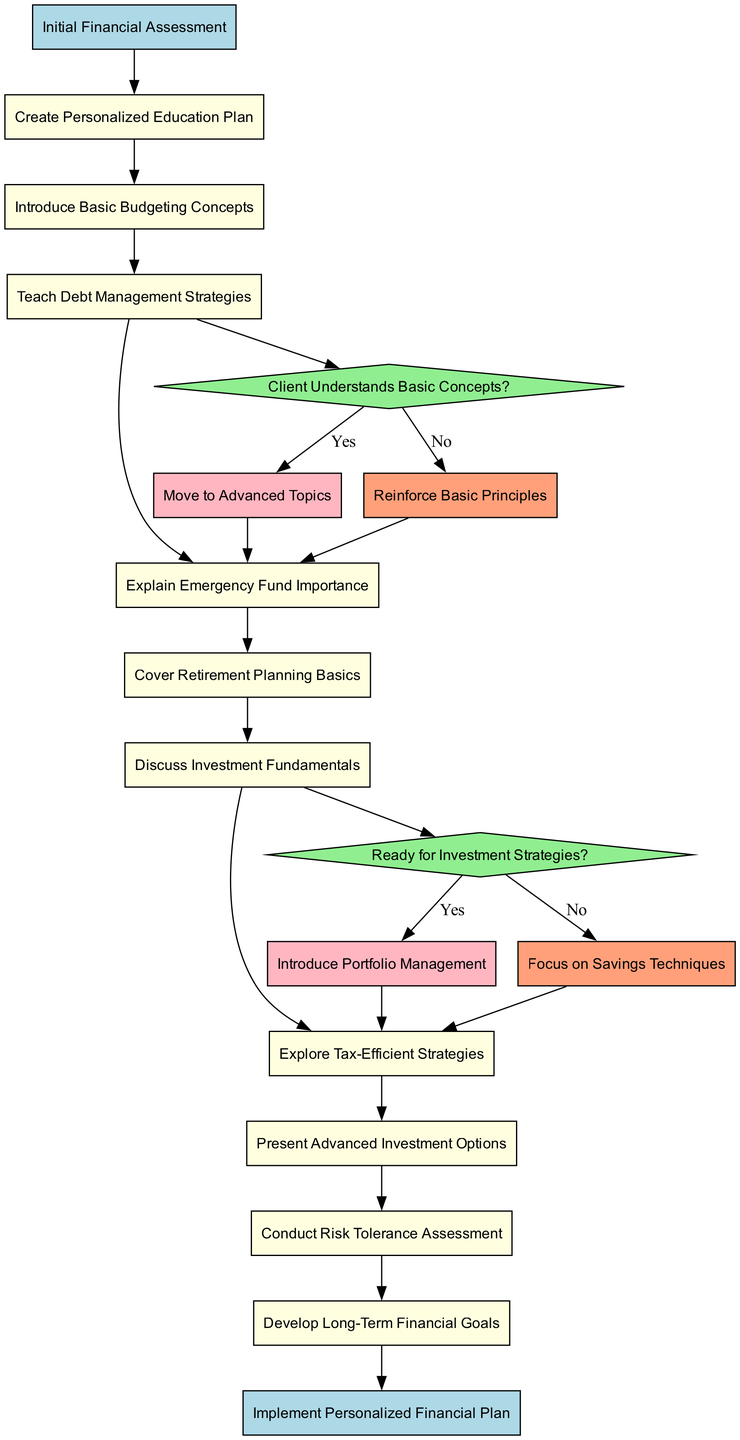What is the starting point of the diagram? The starting point is the node labeled "Initial Financial Assessment," which is explicitly defined as the first node in the diagram.
Answer: Initial Financial Assessment How many main activities are included in the program? The diagram contains a total of 9 activities listed, indicating the range of topics covered in the client education program.
Answer: 9 What question follows the "Explain Emergency Fund Importance" activity? After "Explain Emergency Fund Importance," the diagram indicates the next node is "Cover Retirement Planning Basics," representing the immediate flow of activities.
Answer: Cover Retirement Planning Basics What happens if the client does not understand basic concepts? If the client does not understand basic concepts, the flow directs to "Reinforce Basic Principles," indicating a reinforcement step in the education process.
Answer: Reinforce Basic Principles If the client is ready for investment strategies, what is the next step? If the client is ready for investment strategies, the next step indicated in the diagram is to "Introduce Portfolio Management," which follows the decision node corresponding to this readiness.
Answer: Introduce Portfolio Management How many decision nodes are present in the diagram? The diagram features 2 decision nodes, each presenting a question about the client's understanding and readiness related to the program topics.
Answer: 2 If a client understands basic concepts, what is the next educational phase? Upon understanding basic concepts, the flow leads to "Discuss Investment Fundamentals," transitioning into more complex topics of finance.
Answer: Discuss Investment Fundamentals How does the diagram conclude? The diagram concludes with the node labeled "Implement Personalized Financial Plan," which represents the final output of the education process aimed at the client.
Answer: Implement Personalized Financial Plan What color represents the decision nodes in the diagram? The color representing the decision nodes in the diagram is light green, as specified for that specific node style in the diagram.
Answer: Light Green 